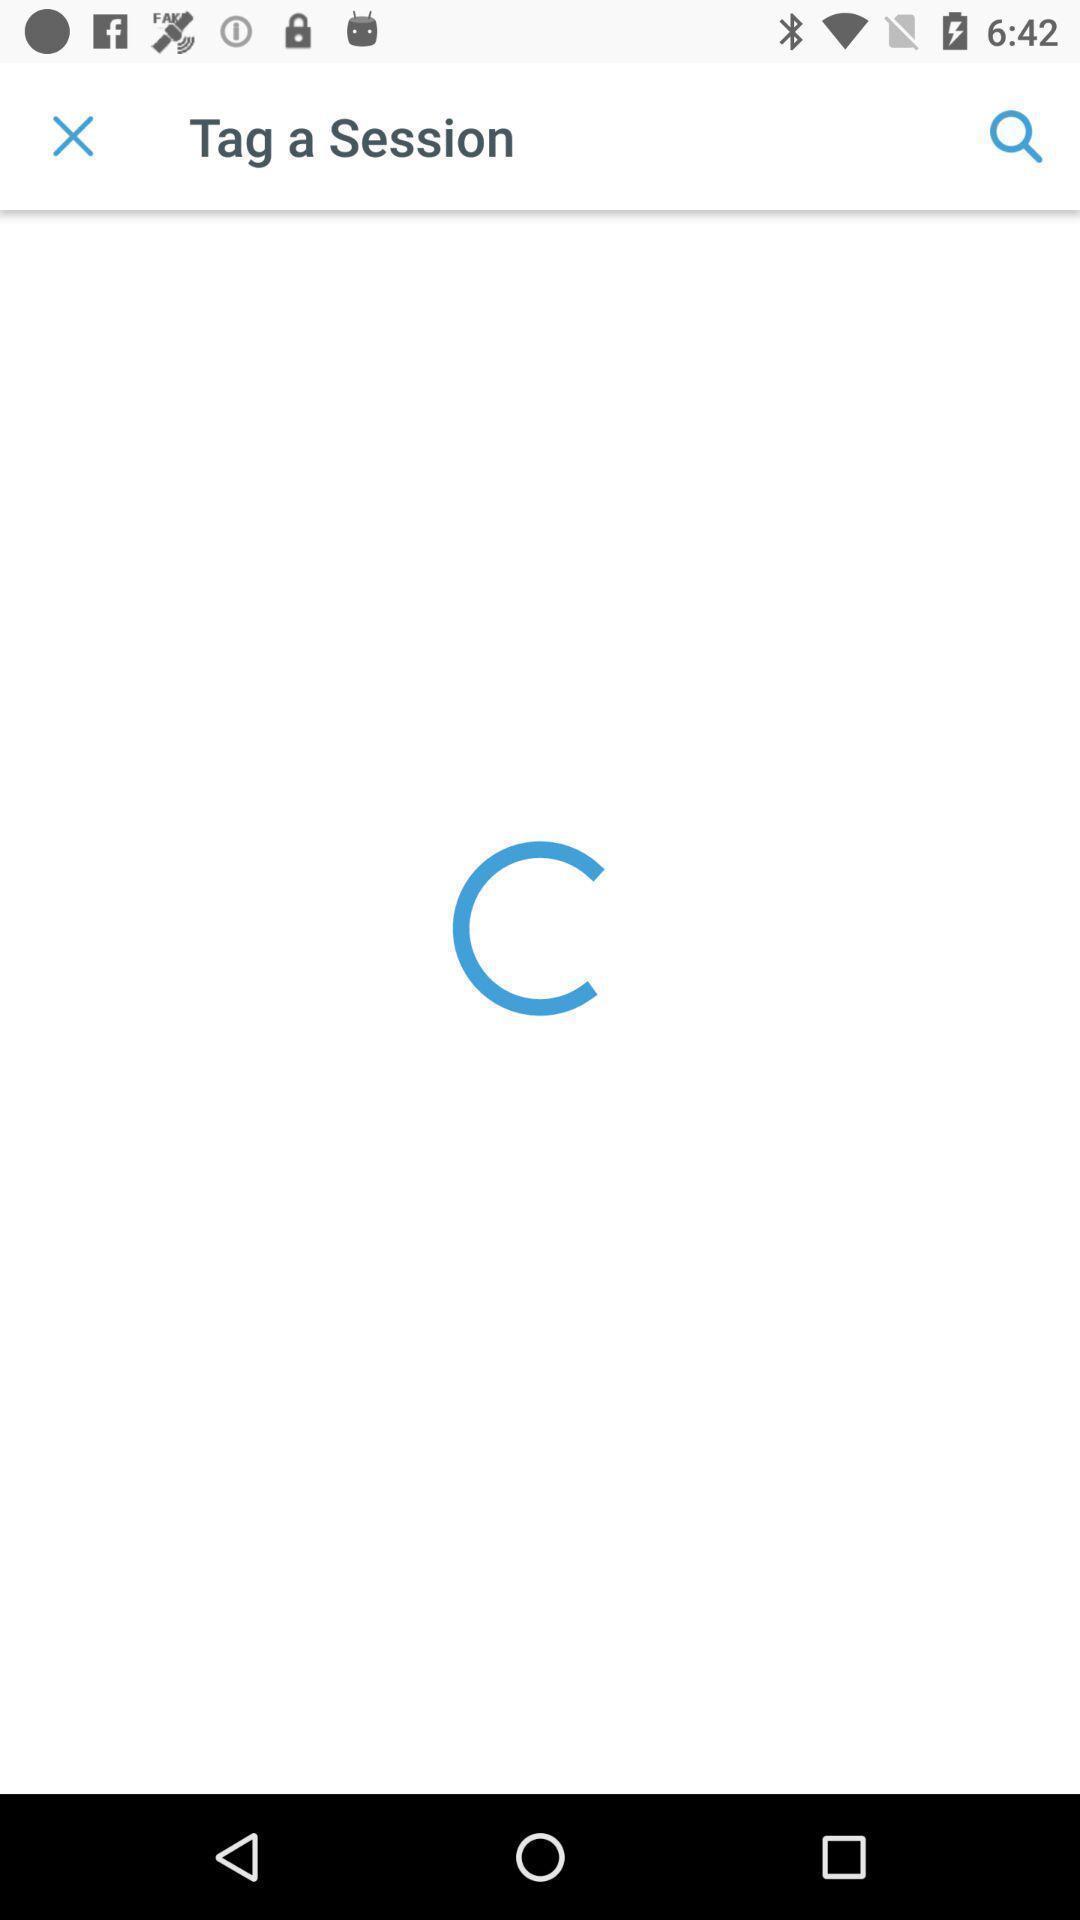Provide a textual representation of this image. Page that is still loading. 